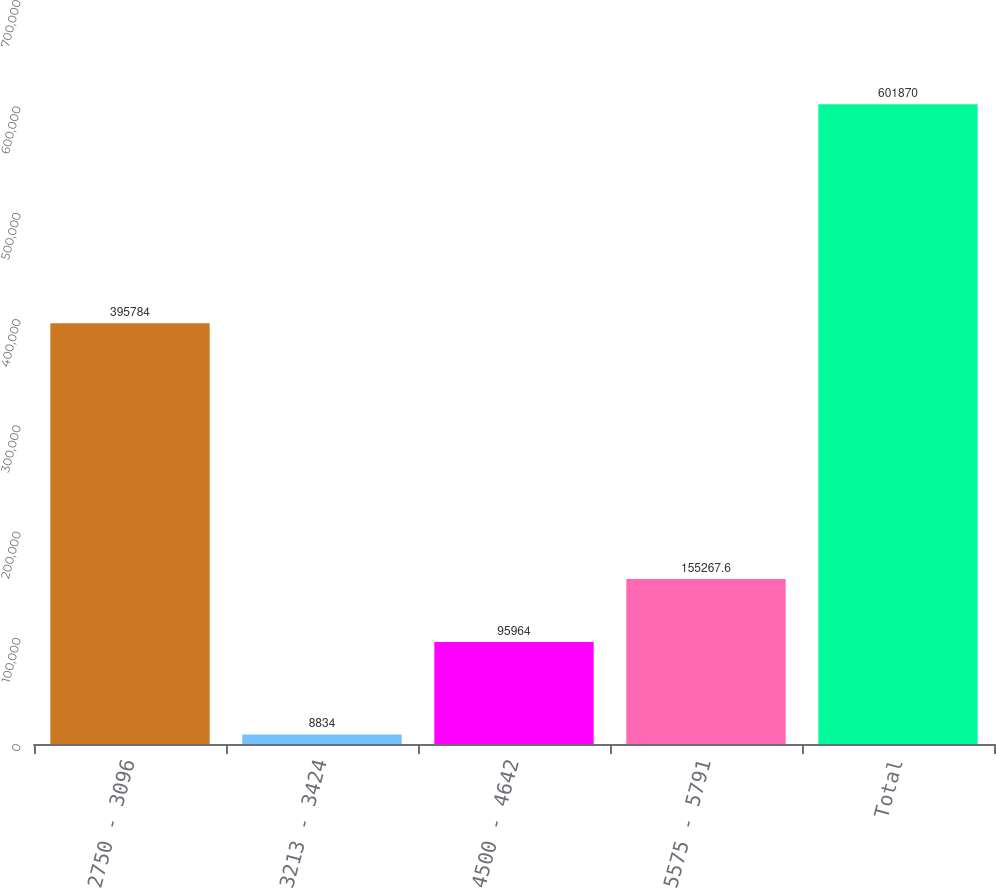Convert chart to OTSL. <chart><loc_0><loc_0><loc_500><loc_500><bar_chart><fcel>2750 - 3096<fcel>3213 - 3424<fcel>4500 - 4642<fcel>5575 - 5791<fcel>Total<nl><fcel>395784<fcel>8834<fcel>95964<fcel>155268<fcel>601870<nl></chart> 